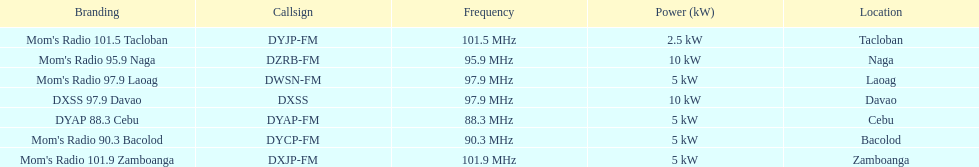What is the radio with the least about of mhz? DYAP 88.3 Cebu. Could you parse the entire table as a dict? {'header': ['Branding', 'Callsign', 'Frequency', 'Power (kW)', 'Location'], 'rows': [["Mom's Radio 101.5 Tacloban", 'DYJP-FM', '101.5\xa0MHz', '2.5\xa0kW', 'Tacloban'], ["Mom's Radio 95.9 Naga", 'DZRB-FM', '95.9\xa0MHz', '10\xa0kW', 'Naga'], ["Mom's Radio 97.9 Laoag", 'DWSN-FM', '97.9\xa0MHz', '5\xa0kW', 'Laoag'], ['DXSS 97.9 Davao', 'DXSS', '97.9\xa0MHz', '10\xa0kW', 'Davao'], ['DYAP 88.3 Cebu', 'DYAP-FM', '88.3\xa0MHz', '5\xa0kW', 'Cebu'], ["Mom's Radio 90.3 Bacolod", 'DYCP-FM', '90.3\xa0MHz', '5\xa0kW', 'Bacolod'], ["Mom's Radio 101.9 Zamboanga", 'DXJP-FM', '101.9\xa0MHz', '5\xa0kW', 'Zamboanga']]} 